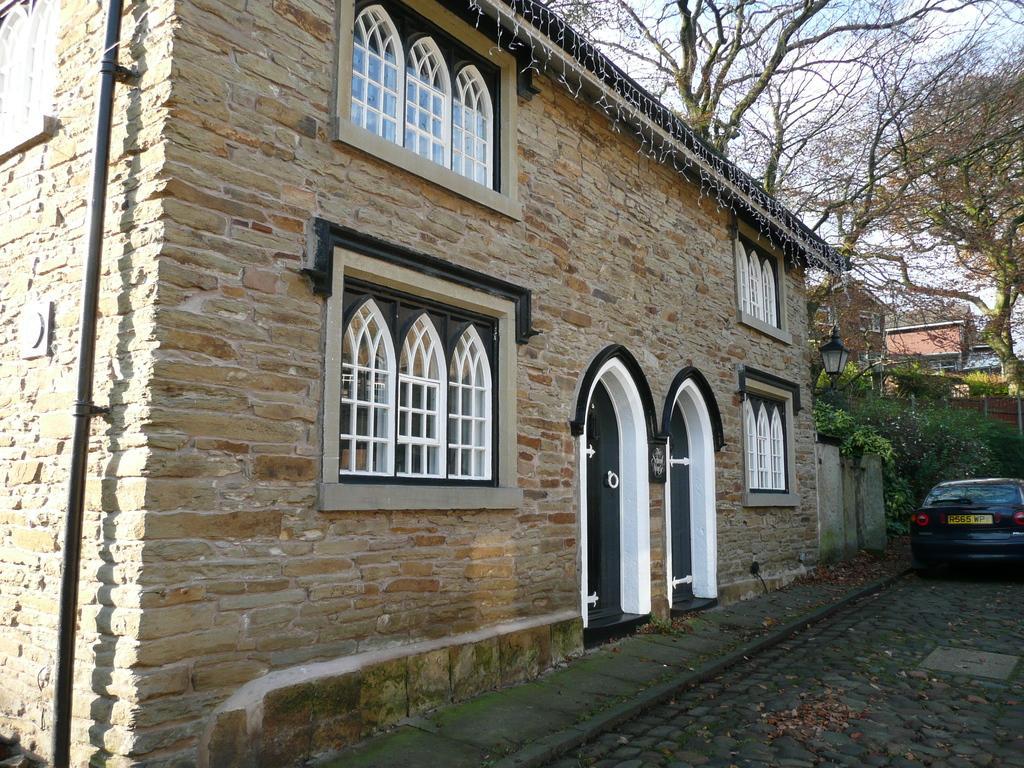Can you describe this image briefly? This is a building with the windows and doors. Here is a car, which is parked. I can see the trees and plants. This looks like a lamp, attached to the wall. I think this is a pipe. I can see the dried leaves lying on the floor. In the background, I can see few other buildings. 